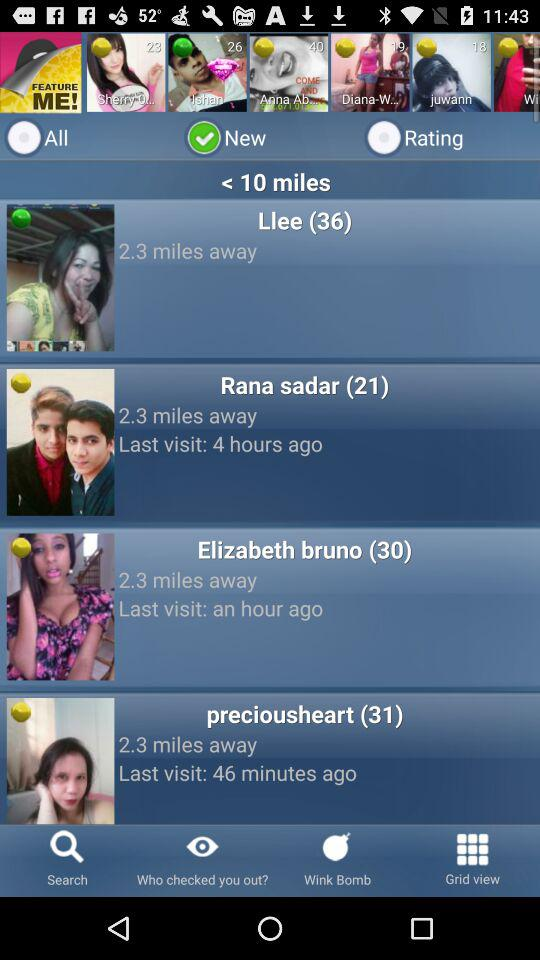What are the names of the new users who are less than ten miles away? The names of the new users are Llee, Rana Sadar, Elizabeth Bruno and "preciousheart". 